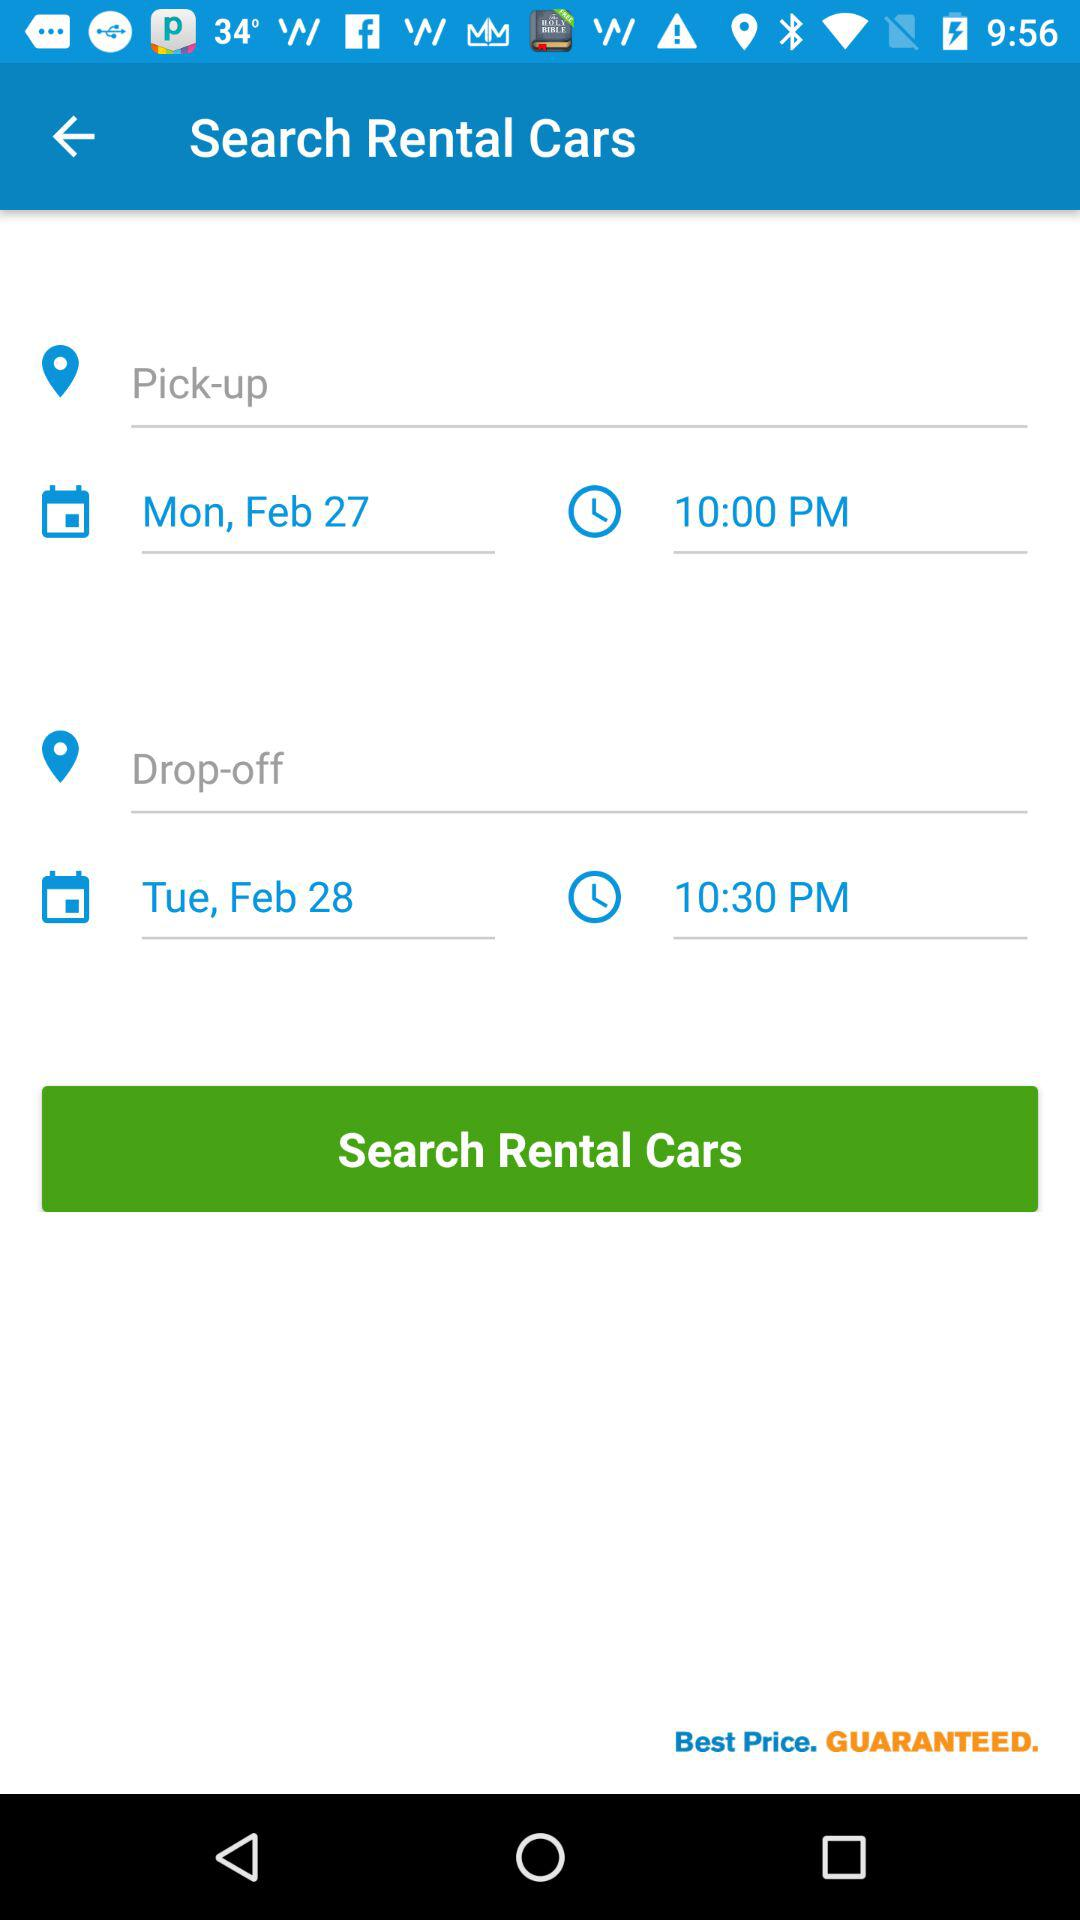What is the pick-up date? The pick-up date is Monday, February 27. 